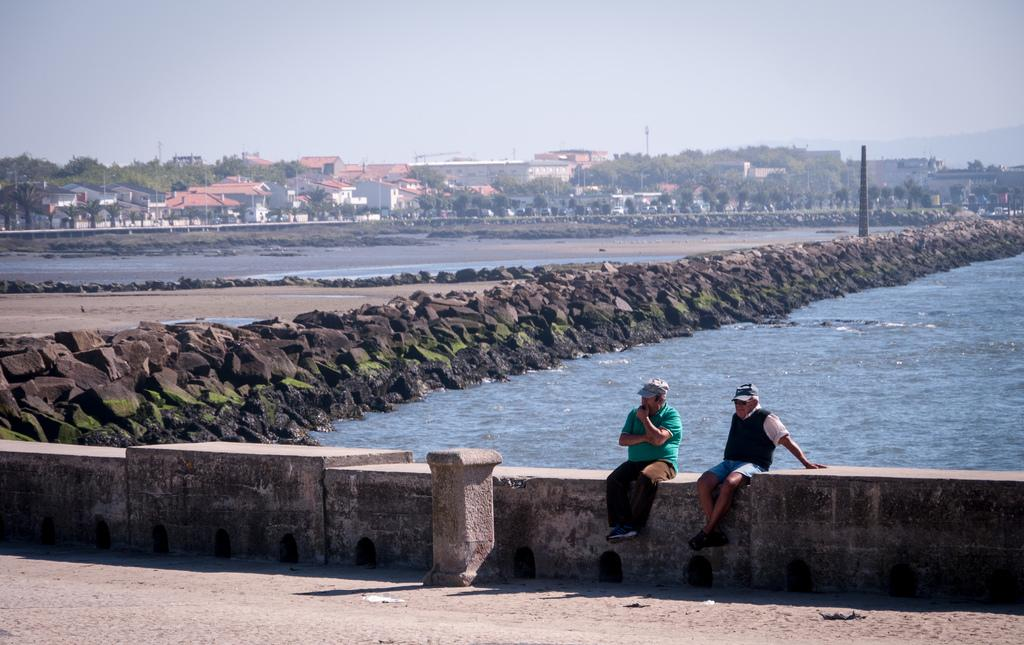What are the people in the image doing? There are persons sitting in the center of the image. What can be seen in the background of the image? Water, stones, buildings, trees, and poles are visible in the background of the image. What type of action is being performed by the waves in the image? There are no waves present in the image, so no action can be attributed to them. 